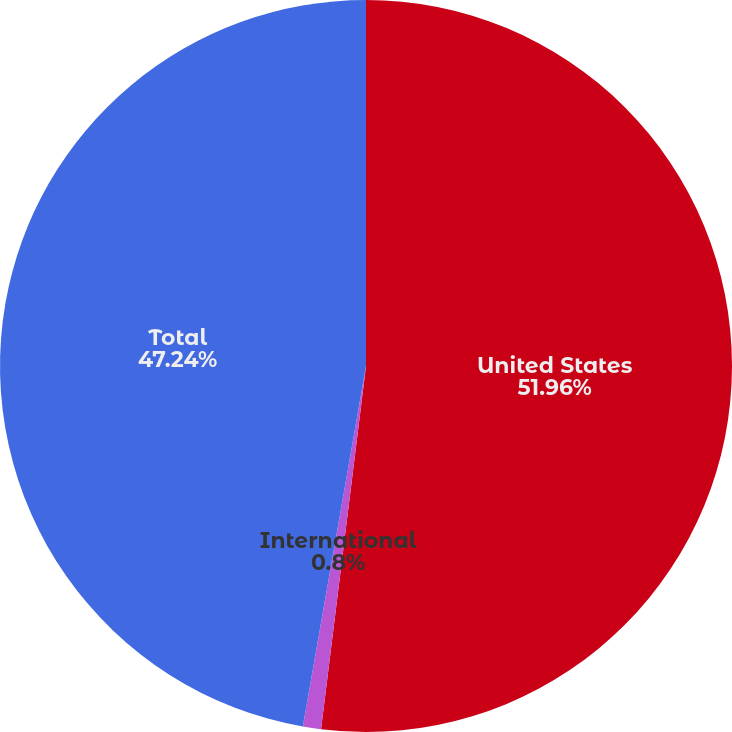Convert chart. <chart><loc_0><loc_0><loc_500><loc_500><pie_chart><fcel>United States<fcel>International<fcel>Total<nl><fcel>51.96%<fcel>0.8%<fcel>47.24%<nl></chart> 